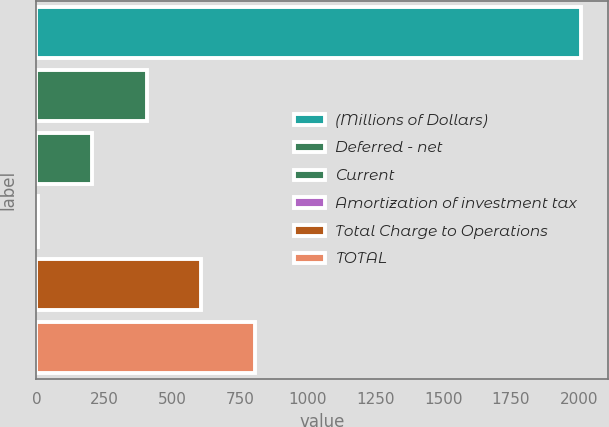Convert chart. <chart><loc_0><loc_0><loc_500><loc_500><bar_chart><fcel>(Millions of Dollars)<fcel>Deferred - net<fcel>Current<fcel>Amortization of investment tax<fcel>Total Charge to Operations<fcel>TOTAL<nl><fcel>2007<fcel>406.2<fcel>206.1<fcel>6<fcel>606.3<fcel>806.4<nl></chart> 